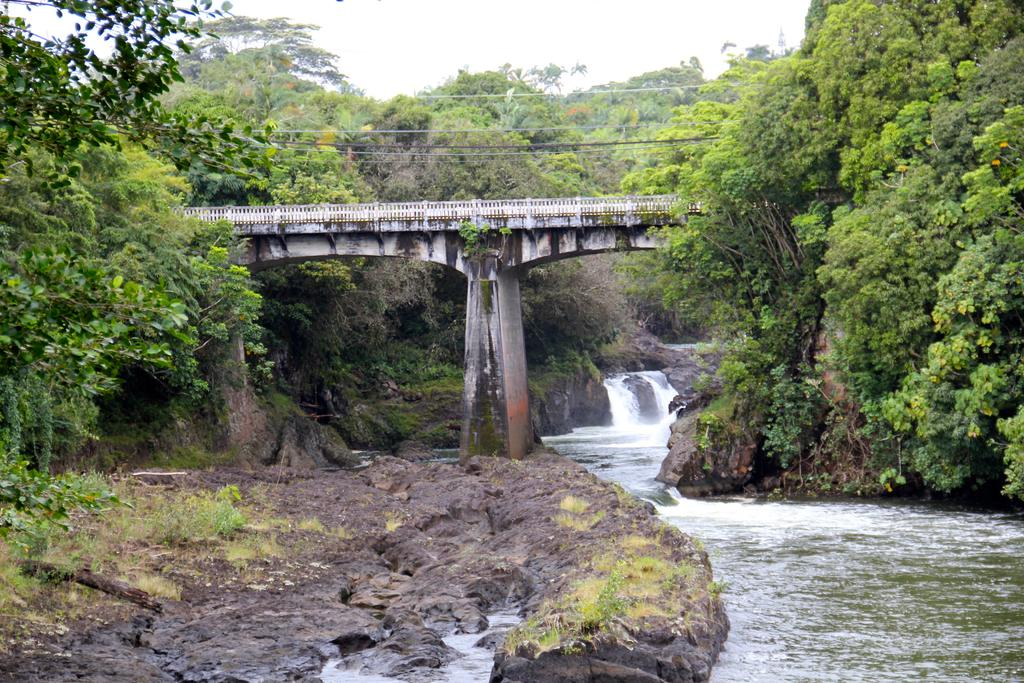What is the main structure in the center of the image? There is a bridge in the center of the image. What else can be seen in the center of the image? There are wires and water in the center of the image. What type of natural features are present in the image? There are mountains, trees, and rocks in the image. What is visible at the top of the image? The sky is visible at the top of the image. What is visible at the bottom of the image? There is water visible at the bottom of the image. How much sugar is dissolved in the water at the bottom of the image? There is no information about sugar in the image, so we cannot determine the amount of sugar dissolved in the water. 